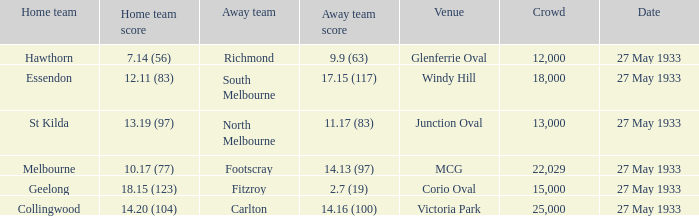During st kilda's home game, what was the number of people in the crowd? 13000.0. 